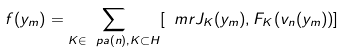<formula> <loc_0><loc_0><loc_500><loc_500>f ( y _ { m } ) = \sum _ { K \in \ p a ( n ) , K \subset H } [ \ m r { J } _ { K } ( y _ { m } ) , F _ { K } ( v _ { n } ( y _ { m } ) ) ]</formula> 